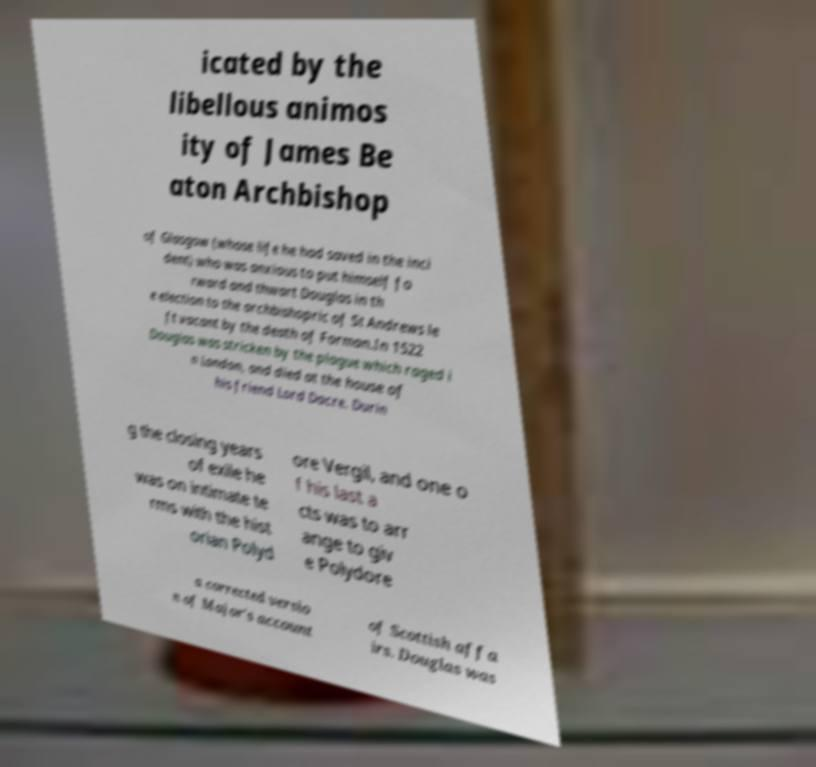Please read and relay the text visible in this image. What does it say? icated by the libellous animos ity of James Be aton Archbishop of Glasgow (whose life he had saved in the inci dent) who was anxious to put himself fo rward and thwart Douglas in th e election to the archbishopric of St Andrews le ft vacant by the death of Forman.In 1522 Douglas was stricken by the plague which raged i n London, and died at the house of his friend Lord Dacre. Durin g the closing years of exile he was on intimate te rms with the hist orian Polyd ore Vergil, and one o f his last a cts was to arr ange to giv e Polydore a corrected versio n of Major's account of Scottish affa irs. Douglas was 